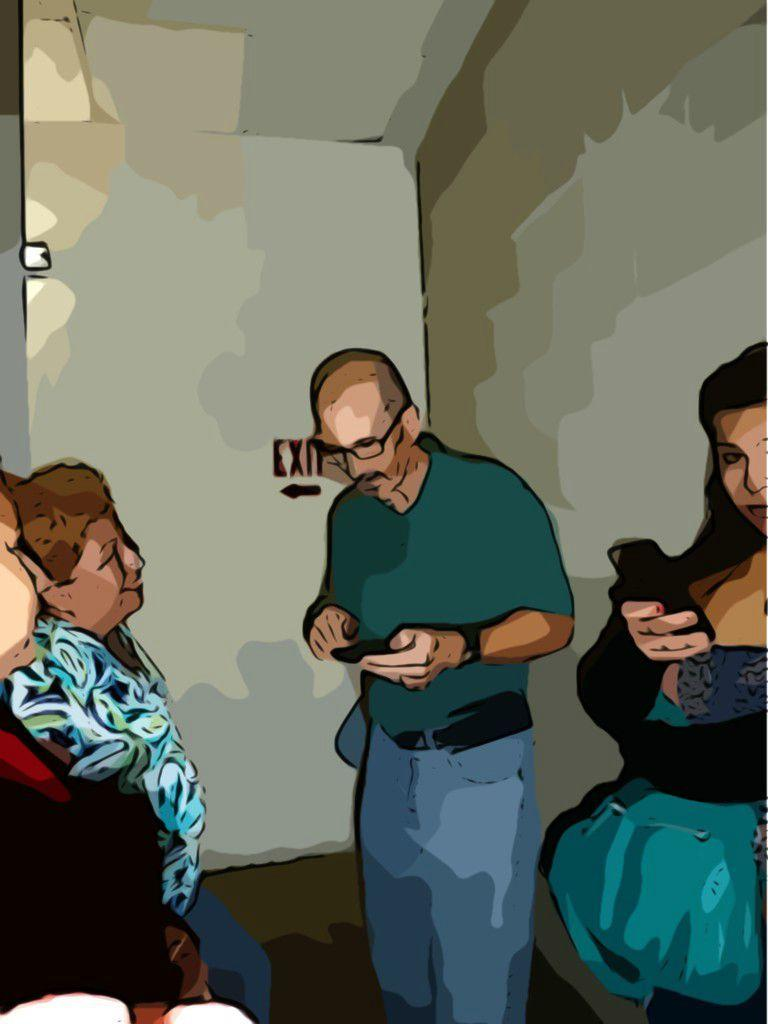What is the main subject of the image? The image contains a painting. What is being depicted in the painting? The painting depicts persons. Can you describe the actions of the persons in the painting? A man is holding an object, and a woman is holding a cellphone in the painting. What can be seen in the background of the painting? There is an exit board in the background of the painting. What type of scale can be seen in the painting? There is no scale present in the painting; it features a man holding an object and a woman holding a cellphone. How many matches are visible in the painting? There are no matches visible in the painting. 